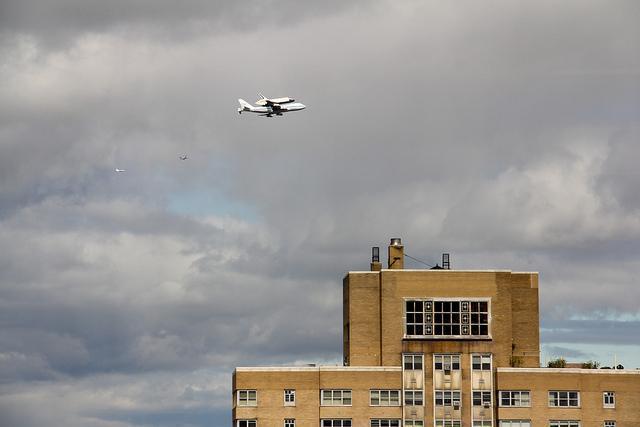What is the plane flying over?
Indicate the correct response and explain using: 'Answer: answer
Rationale: rationale.'
Options: Mountain, building, lake, forest. Answer: building.
Rationale: There are floors and windows 